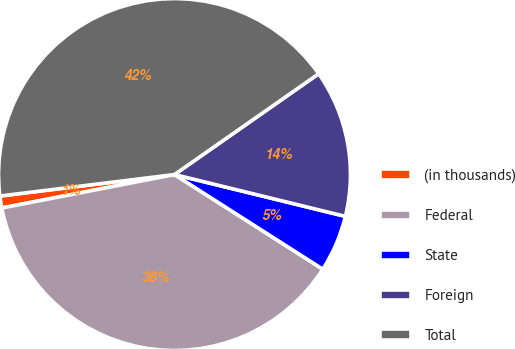Convert chart to OTSL. <chart><loc_0><loc_0><loc_500><loc_500><pie_chart><fcel>(in thousands)<fcel>Federal<fcel>State<fcel>Foreign<fcel>Total<nl><fcel>1.1%<fcel>37.91%<fcel>5.22%<fcel>13.53%<fcel>42.24%<nl></chart> 